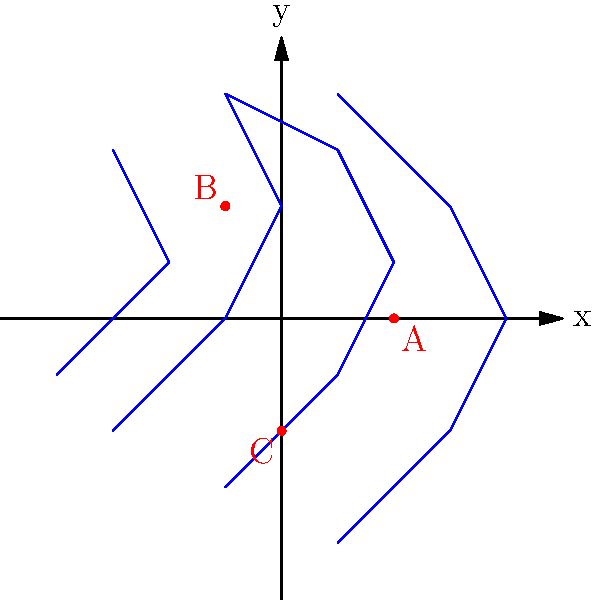Given the topographic map above, where contour lines represent equal elevations and red dots indicate potential dam locations, determine which location (A, B, or C) would be optimal for dam construction. Consider that the ideal location should have the steepest gradient perpendicular to the contour lines and be situated in a narrow section of the valley. Use coordinate transformations to justify your answer. To determine the optimal location for the dam, we need to analyze each potential site using the following criteria:

1. Steepness of the gradient perpendicular to contour lines
2. Narrowness of the valley

Let's examine each location:

A (2,0):
1. The contour lines are relatively far apart, indicating a gentler slope.
2. The valley appears wider at this point.

B (-1,2):
1. The contour lines are closer together, suggesting a steeper gradient.
2. The valley appears to narrow at this location.

C (0,-2):
1. The contour lines are moderately spaced, indicating an average gradient.
2. The valley seems to be of medium width at this point.

To quantify the steepness and perform coordinate transformations, we can:

1. Calculate the gradient at each point by measuring the perpendicular distance between contour lines.
2. Transform the coordinates to align the x-axis with the valley direction and the y-axis perpendicular to it.

For location B, which appears to be the most promising:

1. Gradient calculation:
   Let's assume the contour interval is 10 meters and the distance between contours is approximately 1 unit on our coordinate system.
   Gradient = $\frac{\text{Elevation change}}{\text{Horizontal distance}} = \frac{10\text{ m}}{1\text{ unit}} = 10\text{ m/unit}$

2. Coordinate transformation:
   Rotate the coordinate system by approximately 45° counterclockwise to align with the valley direction.
   Transformation matrix: 
   $$ \begin{bmatrix} \cos 45° & -\sin 45° \\ \sin 45° & \cos 45° \end{bmatrix} = \begin{bmatrix} \frac{\sqrt{2}}{2} & -\frac{\sqrt{2}}{2} \\ \frac{\sqrt{2}}{2} & \frac{\sqrt{2}}{2} \end{bmatrix} $$
   
   New coordinates of B: 
   $$ \begin{bmatrix} \frac{\sqrt{2}}{2} & -\frac{\sqrt{2}}{2} \\ \frac{\sqrt{2}}{2} & \frac{\sqrt{2}}{2} \end{bmatrix} \begin{bmatrix} -1 \\ 2 \end{bmatrix} = \begin{bmatrix} -2.12 \\ 0.71 \end{bmatrix} $$

   The small y-coordinate (0.71) in the transformed system indicates a narrow valley at this location.

Based on this analysis, location B (-1,2) is the optimal choice for dam construction due to its steeper gradient and narrower valley cross-section.
Answer: Location B (-1,2) 